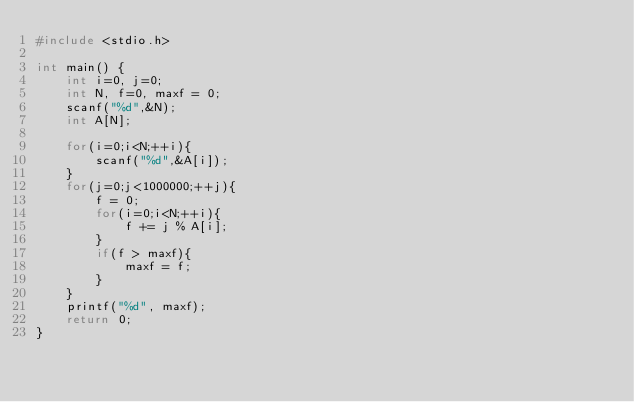Convert code to text. <code><loc_0><loc_0><loc_500><loc_500><_C_>#include <stdio.h>

int main() {
    int i=0, j=0;
    int N, f=0, maxf = 0;
    scanf("%d",&N);
    int A[N];

    for(i=0;i<N;++i){
        scanf("%d",&A[i]);
    }
    for(j=0;j<1000000;++j){
        f = 0;
        for(i=0;i<N;++i){
            f += j % A[i];
        }
        if(f > maxf){
            maxf = f;
        }
    }
    printf("%d", maxf);
    return 0;
}</code> 